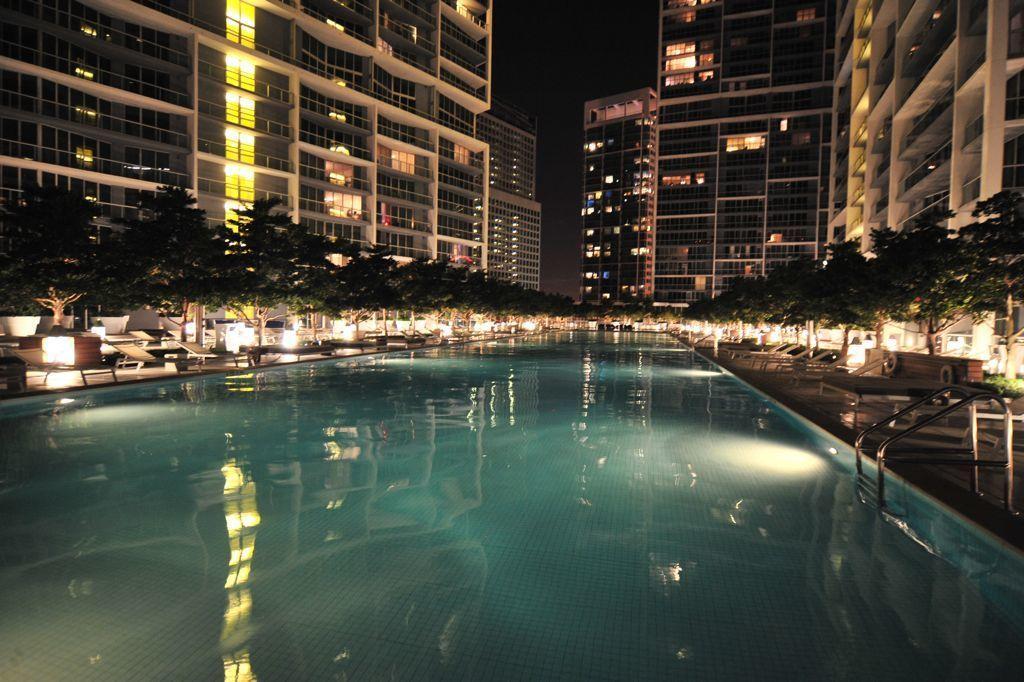In one or two sentences, can you explain what this image depicts? In this picture I can see there is a swimming pool, there are a few chairs, trees and lights. There are a few buildings and it has glass windows and the sky is dark. 